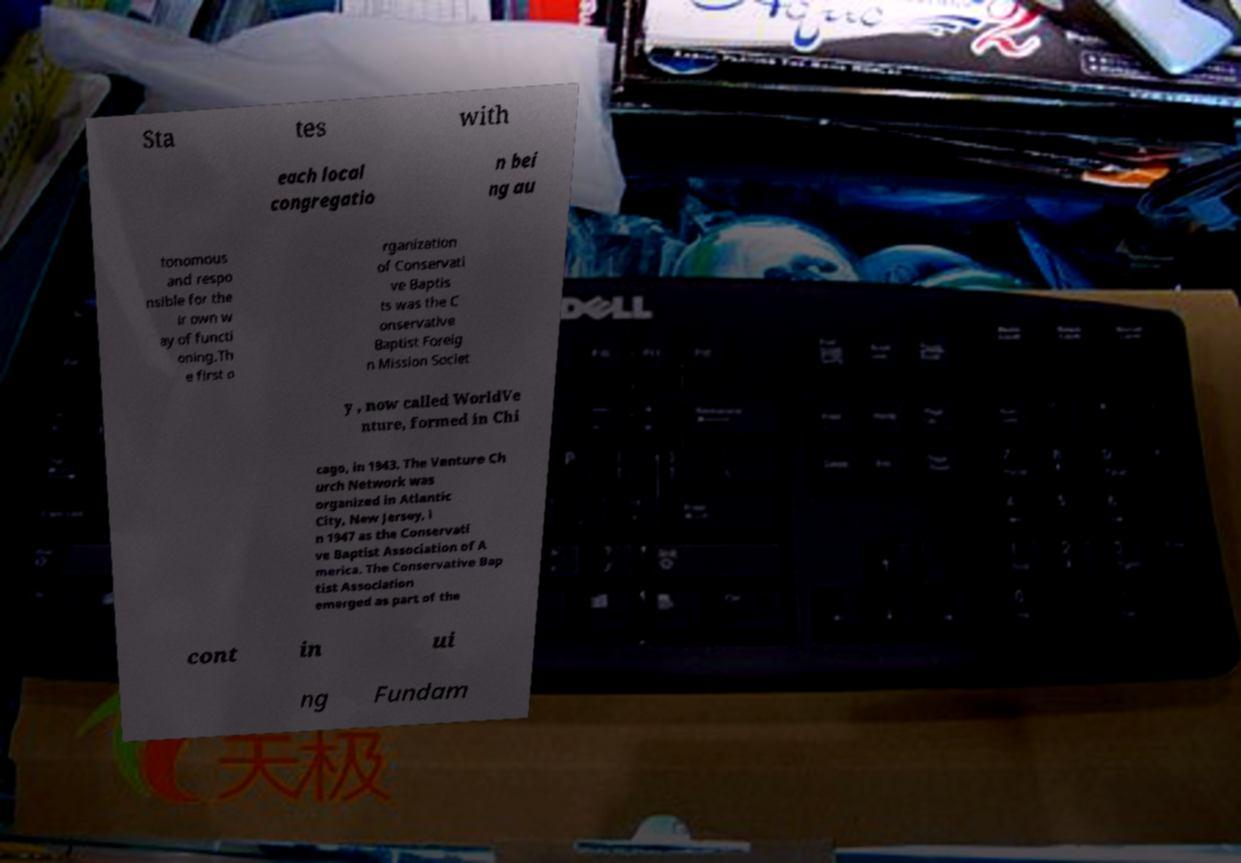Could you assist in decoding the text presented in this image and type it out clearly? Sta tes with each local congregatio n bei ng au tonomous and respo nsible for the ir own w ay of functi oning.Th e first o rganization of Conservati ve Baptis ts was the C onservative Baptist Foreig n Mission Societ y , now called WorldVe nture, formed in Chi cago, in 1943. The Venture Ch urch Network was organized in Atlantic City, New Jersey, i n 1947 as the Conservati ve Baptist Association of A merica. The Conservative Bap tist Association emerged as part of the cont in ui ng Fundam 